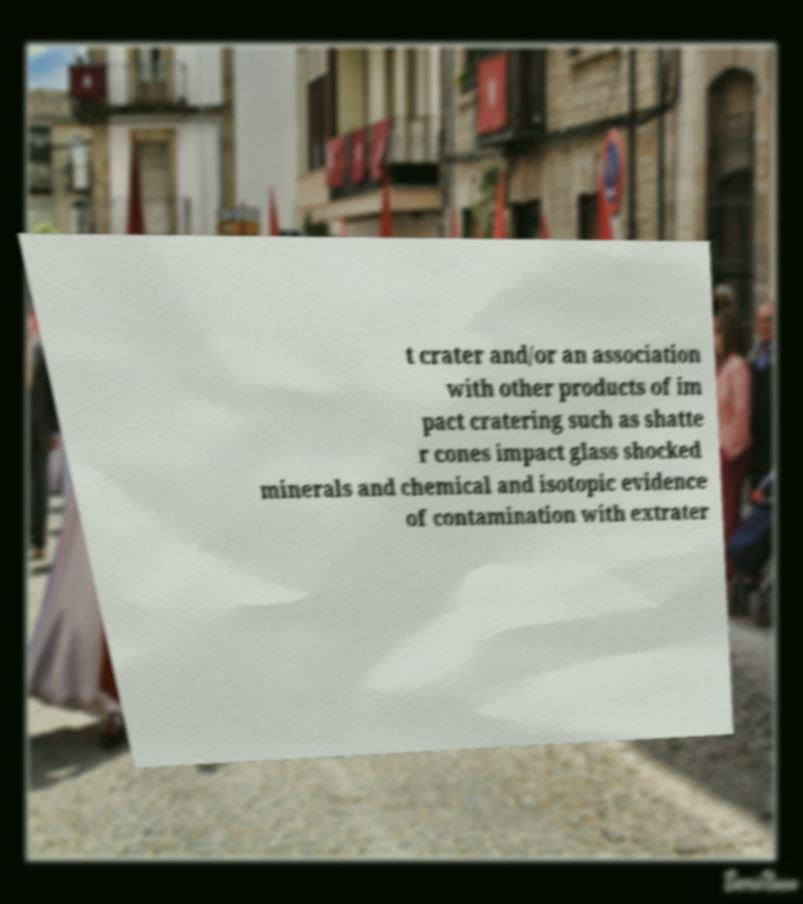Can you accurately transcribe the text from the provided image for me? t crater and/or an association with other products of im pact cratering such as shatte r cones impact glass shocked minerals and chemical and isotopic evidence of contamination with extrater 